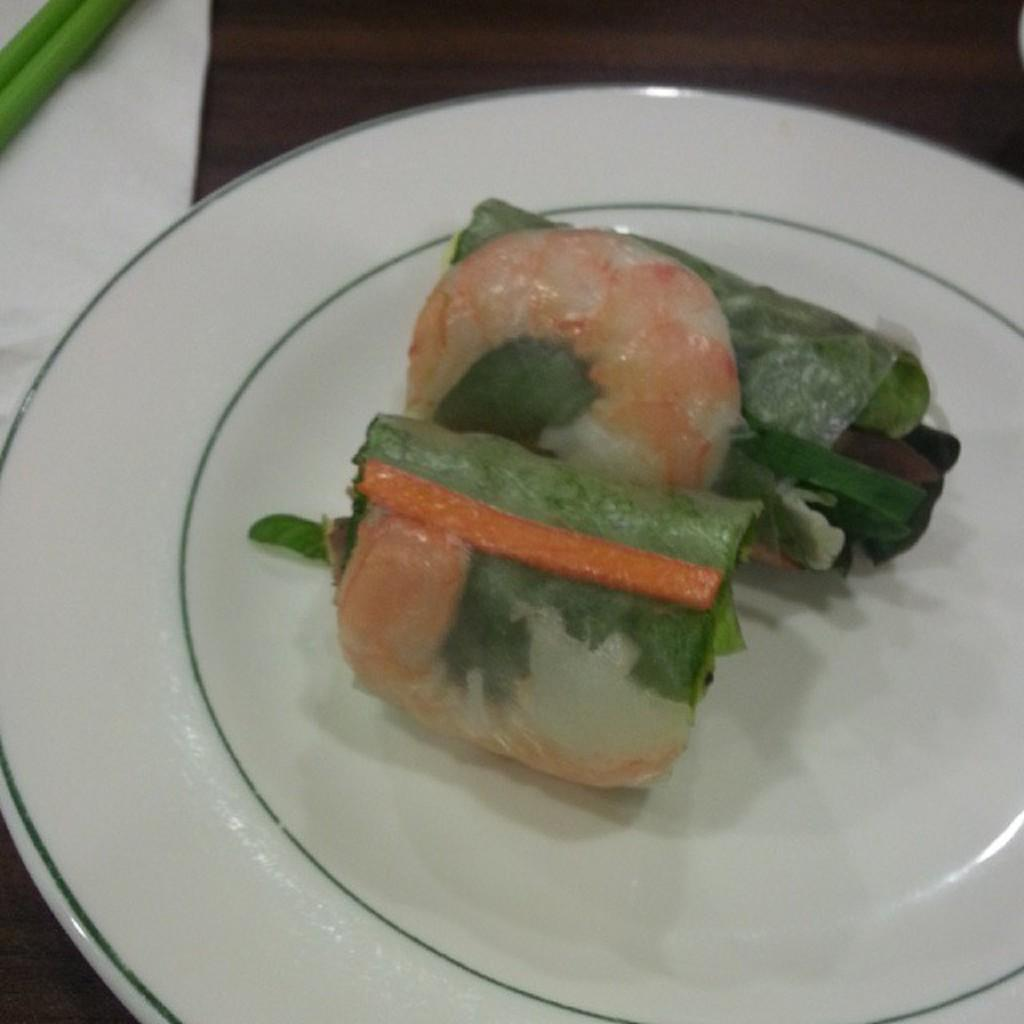What is on the plate in the image? There is a food item on a plate in the image. What piece of furniture is present in the image? There is a table in the image. How many snakes are crawling on the table in the image? There are no snakes present in the image; it only features a food item on a plate and a table. What type of coach is visible in the image? There is no coach present in the image. 